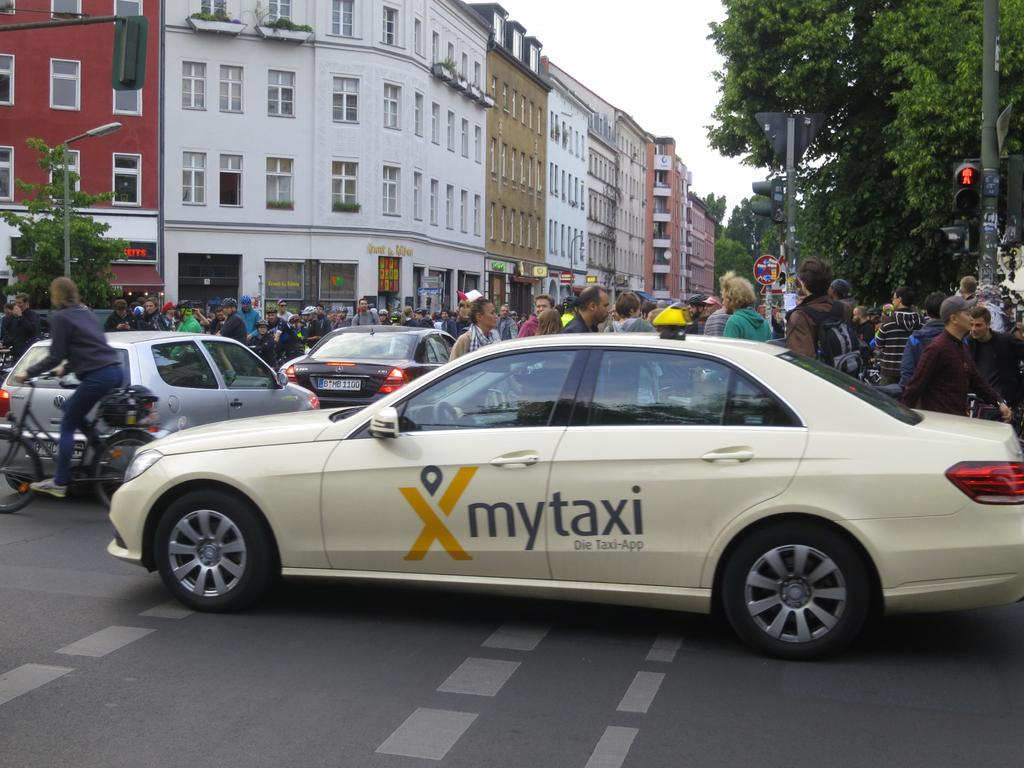<image>
Relay a brief, clear account of the picture shown. A white taxi drives next to the corner of a busy pedestrian corner. 